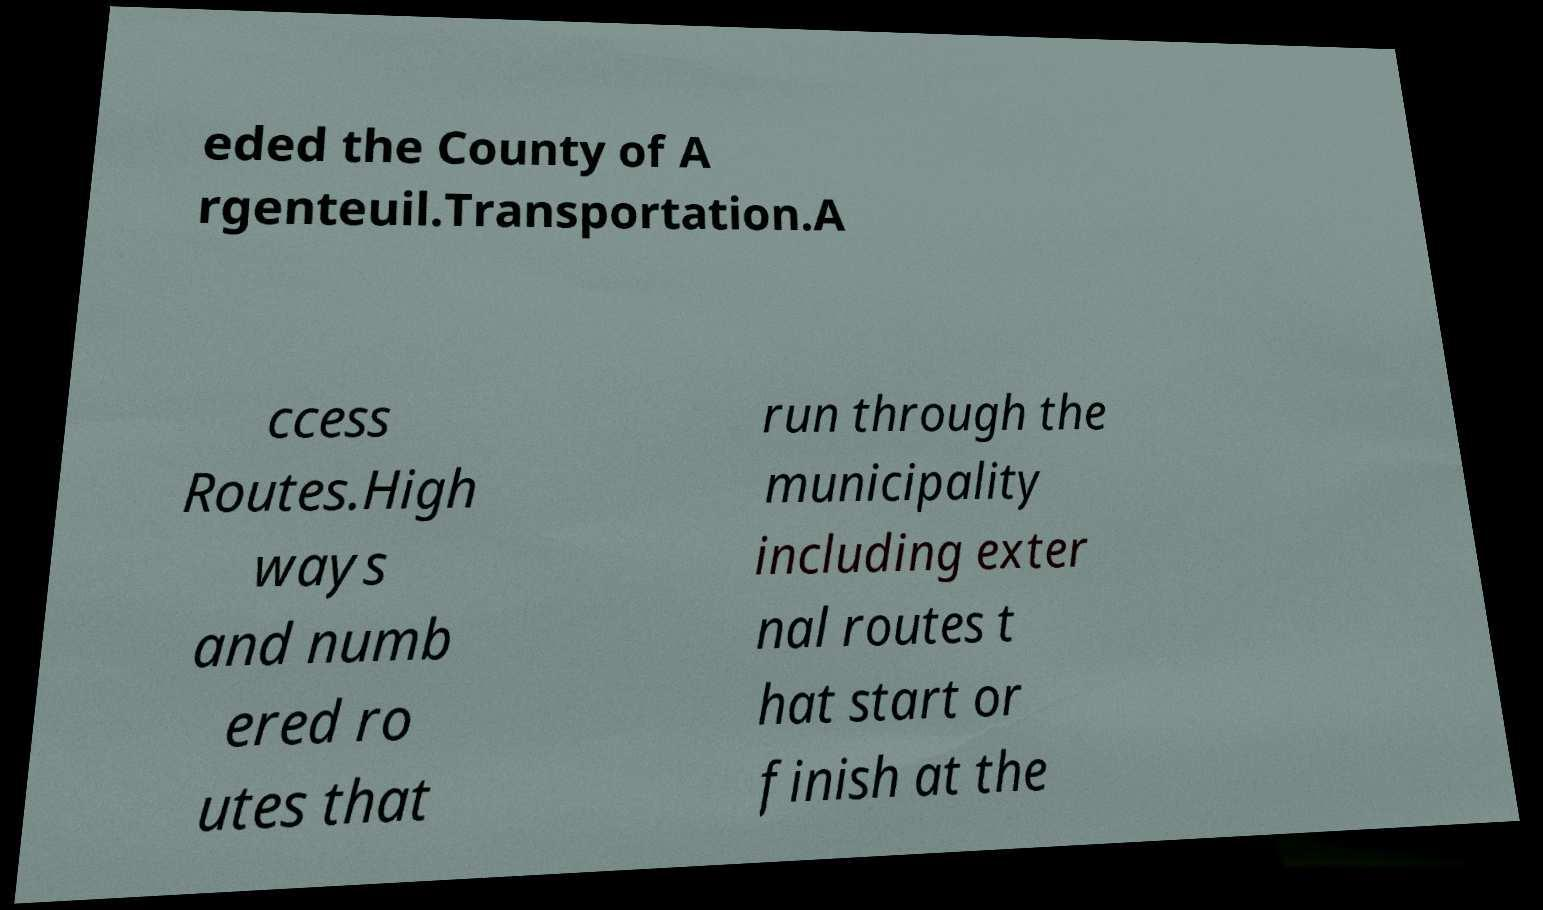What messages or text are displayed in this image? I need them in a readable, typed format. eded the County of A rgenteuil.Transportation.A ccess Routes.High ways and numb ered ro utes that run through the municipality including exter nal routes t hat start or finish at the 